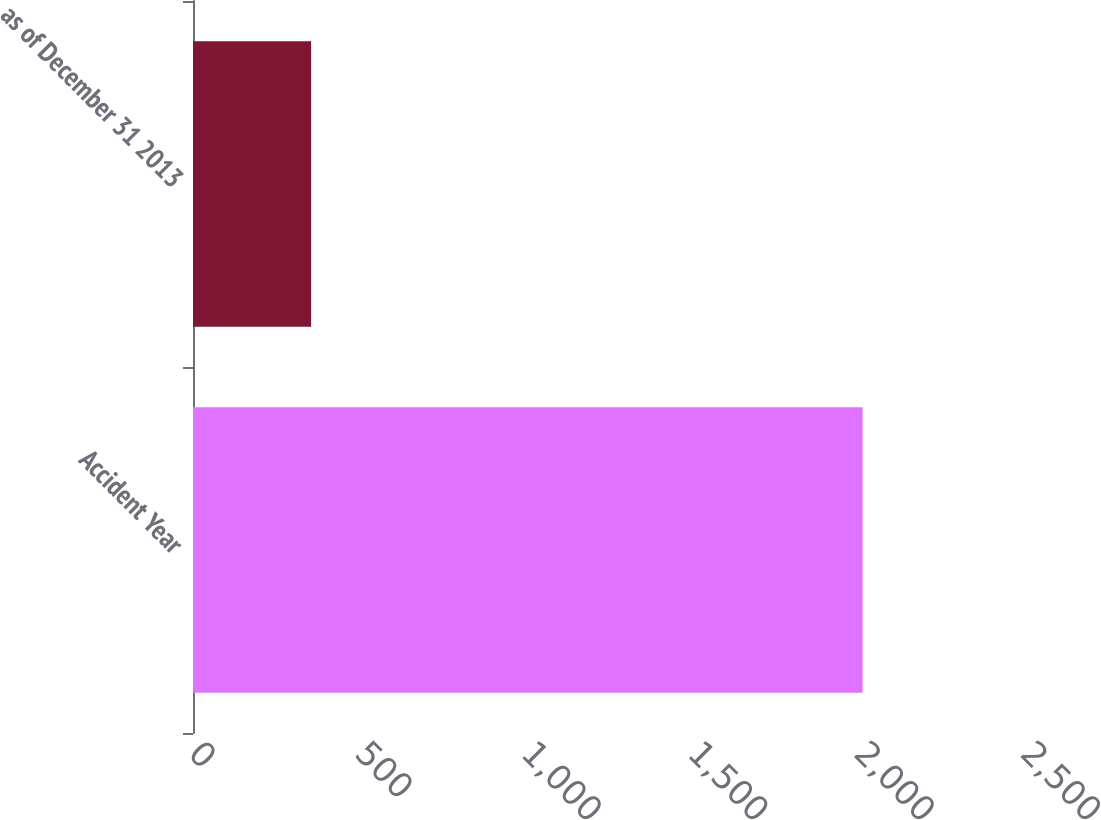Convert chart to OTSL. <chart><loc_0><loc_0><loc_500><loc_500><bar_chart><fcel>Accident Year<fcel>as of December 31 2013<nl><fcel>2012<fcel>355<nl></chart> 